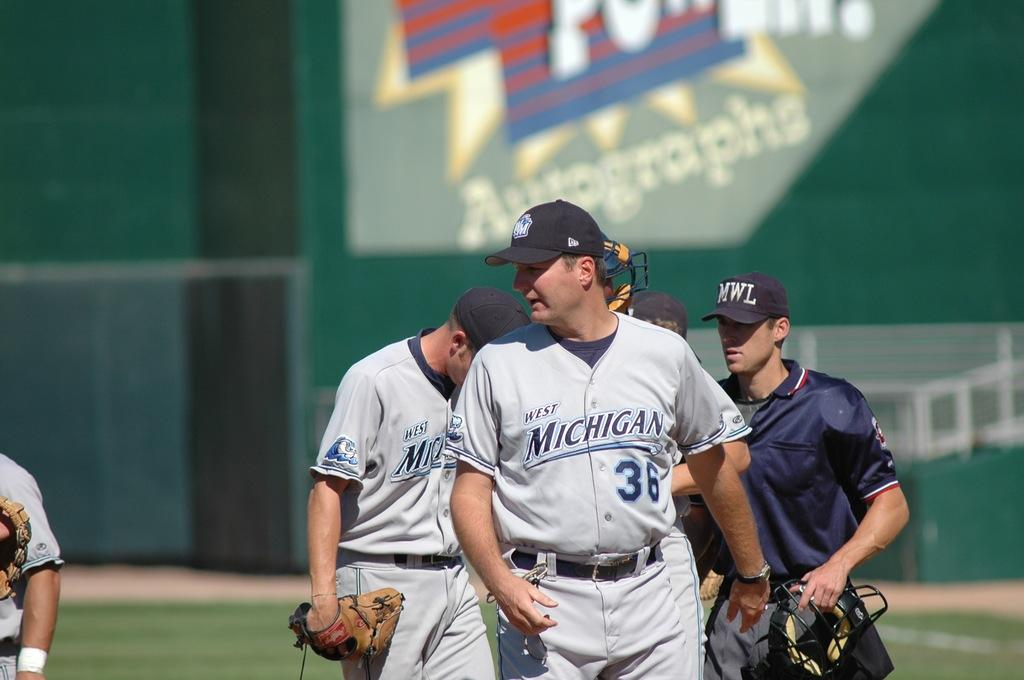<image>
Summarize the visual content of the image. the umpire and two players from the michigan baseball team standing on the field 